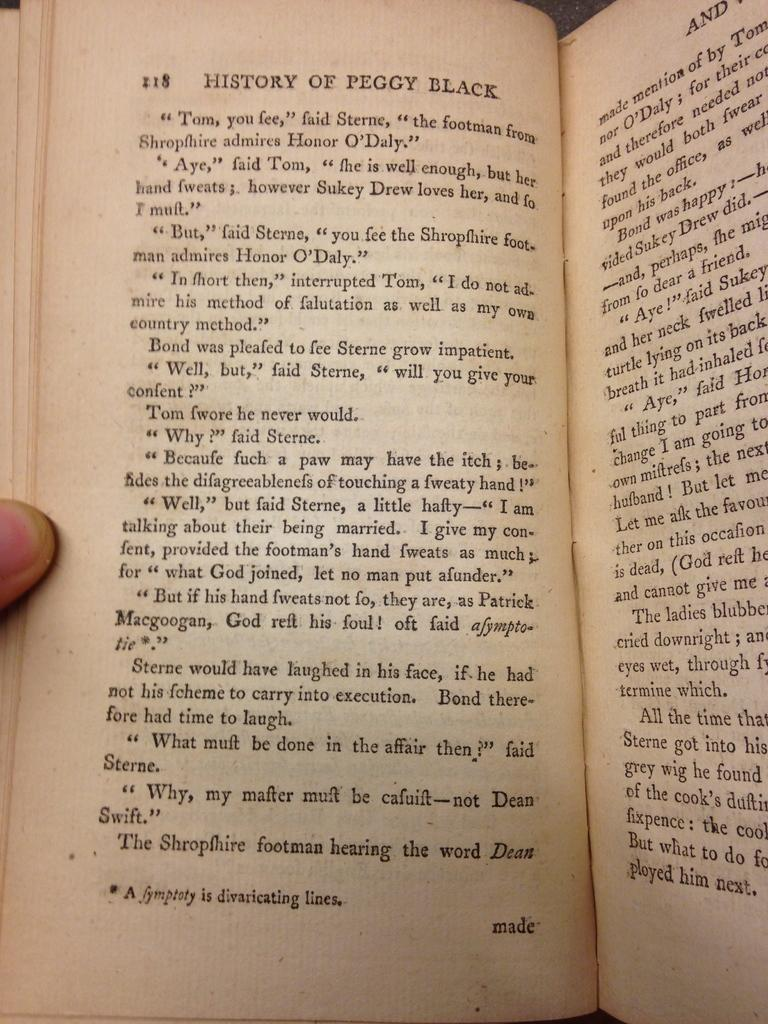<image>
Relay a brief, clear account of the picture shown. A book opened to page 218 called the history of peggy black 